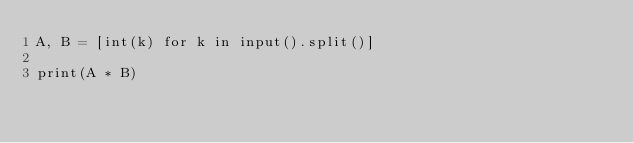<code> <loc_0><loc_0><loc_500><loc_500><_Python_>A, B = [int(k) for k in input().split()]

print(A * B)
</code> 